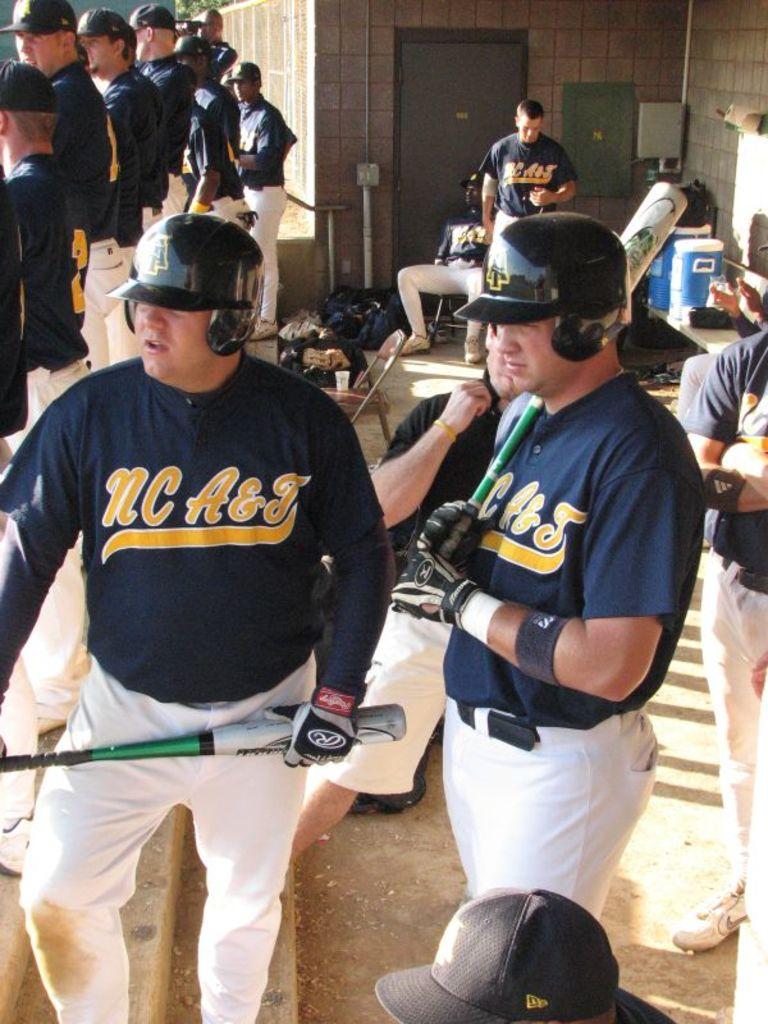What team do the players play for?
Provide a short and direct response. Nc a&j. 